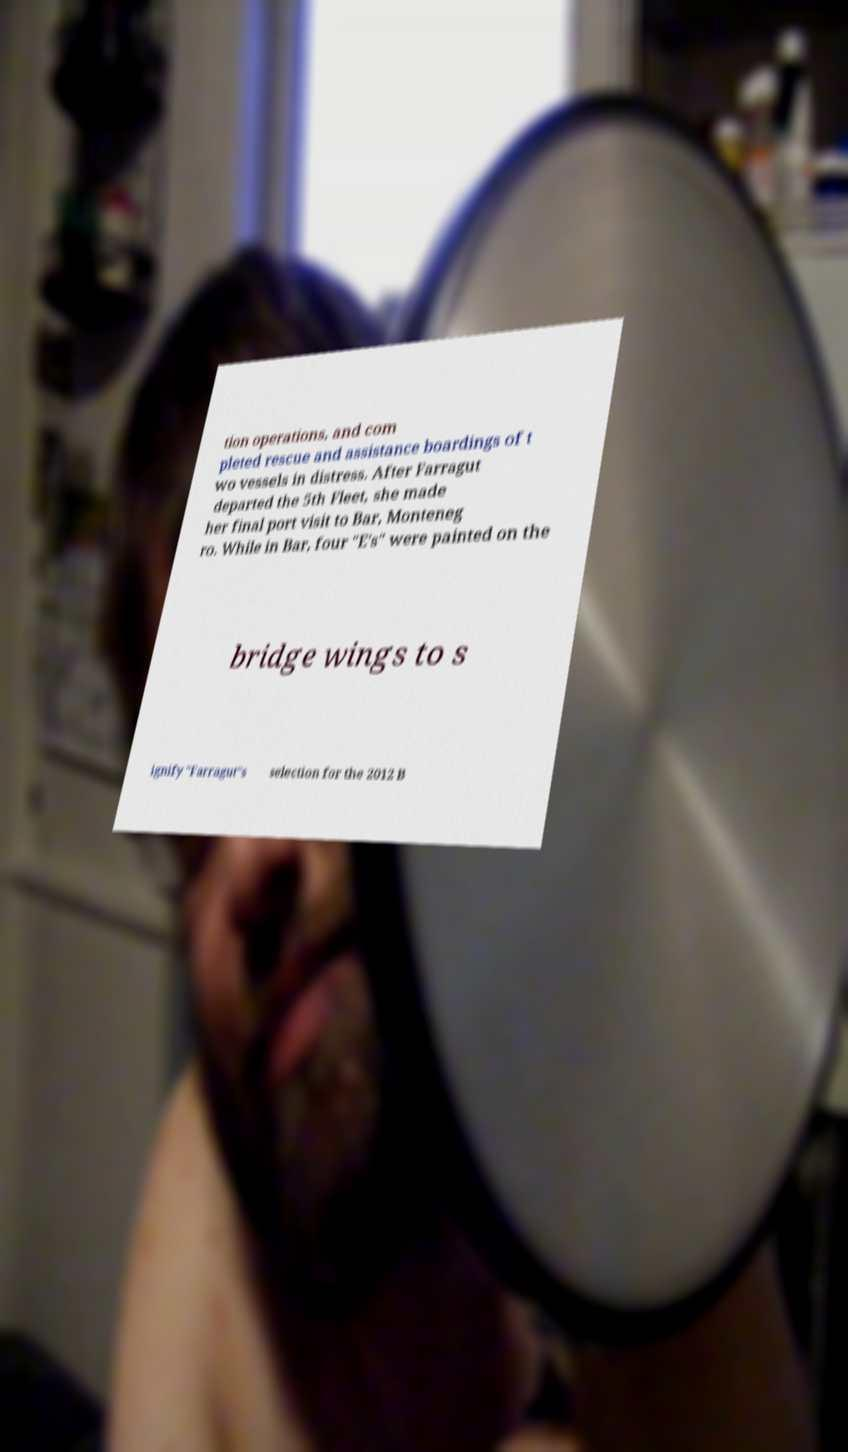Please identify and transcribe the text found in this image. tion operations, and com pleted rescue and assistance boardings of t wo vessels in distress. After Farragut departed the 5th Fleet, she made her final port visit to Bar, Monteneg ro. While in Bar, four "E's" were painted on the bridge wings to s ignify "Farragut"s selection for the 2012 B 